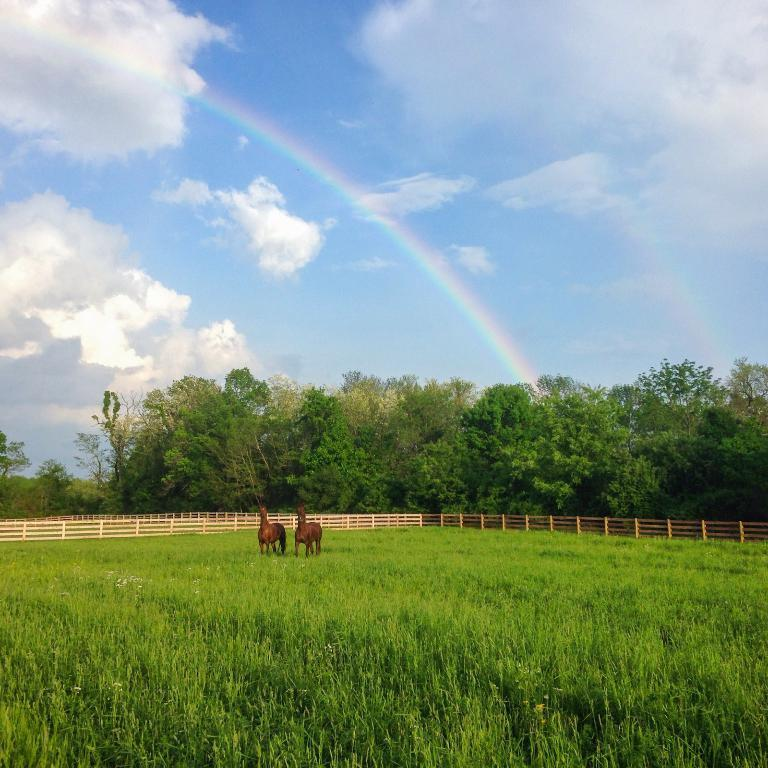What can be seen in the grass in the image? There are two animals standing in the grass. What type of barrier is present in the image? There is a wooden fence in the image. What type of vegetation is visible in the image? There are trees in the image. What is visible in the sky in the image? The sky is visible in the image, and there are clouds and a rainbow present. What type of soap is being used to clean the crook in the image? There is no crook or soap present in the image. What type of horses are depicted in the image? There are no horses depicted in the image; it features two animals, but their species is not specified. 